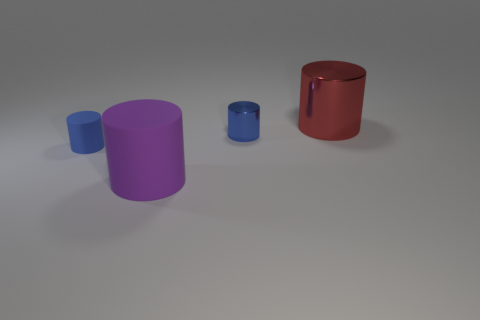Subtract all red cylinders. How many cylinders are left? 3 Subtract all red metallic cylinders. How many cylinders are left? 3 Subtract 3 cylinders. How many cylinders are left? 1 Add 1 rubber cylinders. How many objects exist? 5 Subtract all green balls. How many brown cylinders are left? 0 Subtract all purple rubber cylinders. Subtract all yellow objects. How many objects are left? 3 Add 1 large cylinders. How many large cylinders are left? 3 Add 3 big red shiny cylinders. How many big red shiny cylinders exist? 4 Subtract 0 brown balls. How many objects are left? 4 Subtract all gray cylinders. Subtract all purple spheres. How many cylinders are left? 4 